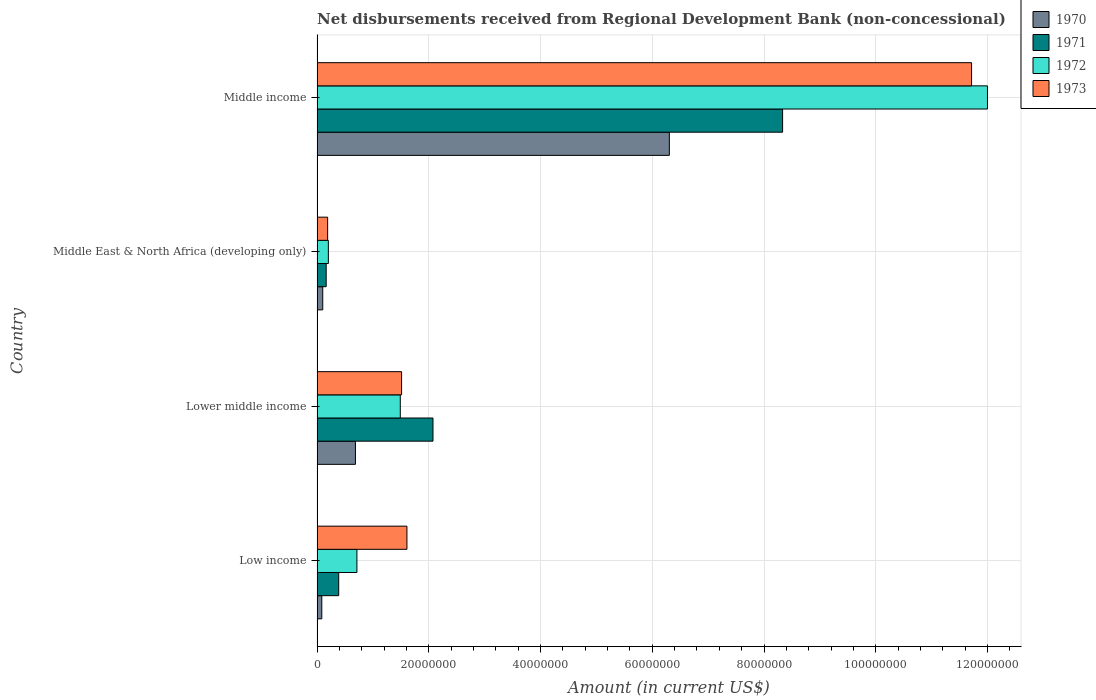How many different coloured bars are there?
Your answer should be very brief. 4. Are the number of bars per tick equal to the number of legend labels?
Provide a short and direct response. Yes. What is the label of the 2nd group of bars from the top?
Your response must be concise. Middle East & North Africa (developing only). In how many cases, is the number of bars for a given country not equal to the number of legend labels?
Provide a succinct answer. 0. What is the amount of disbursements received from Regional Development Bank in 1970 in Lower middle income?
Your response must be concise. 6.87e+06. Across all countries, what is the maximum amount of disbursements received from Regional Development Bank in 1970?
Keep it short and to the point. 6.31e+07. Across all countries, what is the minimum amount of disbursements received from Regional Development Bank in 1972?
Make the answer very short. 2.02e+06. In which country was the amount of disbursements received from Regional Development Bank in 1972 maximum?
Your answer should be very brief. Middle income. What is the total amount of disbursements received from Regional Development Bank in 1972 in the graph?
Provide a succinct answer. 1.44e+08. What is the difference between the amount of disbursements received from Regional Development Bank in 1971 in Low income and that in Middle income?
Your answer should be very brief. -7.94e+07. What is the difference between the amount of disbursements received from Regional Development Bank in 1973 in Middle East & North Africa (developing only) and the amount of disbursements received from Regional Development Bank in 1972 in Low income?
Your response must be concise. -5.24e+06. What is the average amount of disbursements received from Regional Development Bank in 1973 per country?
Offer a terse response. 3.76e+07. What is the difference between the amount of disbursements received from Regional Development Bank in 1972 and amount of disbursements received from Regional Development Bank in 1970 in Middle East & North Africa (developing only)?
Provide a succinct answer. 1.00e+06. What is the ratio of the amount of disbursements received from Regional Development Bank in 1971 in Low income to that in Middle income?
Keep it short and to the point. 0.05. Is the difference between the amount of disbursements received from Regional Development Bank in 1972 in Lower middle income and Middle income greater than the difference between the amount of disbursements received from Regional Development Bank in 1970 in Lower middle income and Middle income?
Provide a short and direct response. No. What is the difference between the highest and the second highest amount of disbursements received from Regional Development Bank in 1972?
Offer a terse response. 1.05e+08. What is the difference between the highest and the lowest amount of disbursements received from Regional Development Bank in 1972?
Your answer should be compact. 1.18e+08. What does the 2nd bar from the bottom in Middle East & North Africa (developing only) represents?
Your answer should be compact. 1971. Is it the case that in every country, the sum of the amount of disbursements received from Regional Development Bank in 1973 and amount of disbursements received from Regional Development Bank in 1971 is greater than the amount of disbursements received from Regional Development Bank in 1972?
Your answer should be very brief. Yes. How many bars are there?
Provide a succinct answer. 16. How many countries are there in the graph?
Make the answer very short. 4. Are the values on the major ticks of X-axis written in scientific E-notation?
Your answer should be very brief. No. Does the graph contain grids?
Make the answer very short. Yes. Where does the legend appear in the graph?
Provide a succinct answer. Top right. How many legend labels are there?
Provide a short and direct response. 4. What is the title of the graph?
Offer a very short reply. Net disbursements received from Regional Development Bank (non-concessional). What is the label or title of the Y-axis?
Your answer should be very brief. Country. What is the Amount (in current US$) of 1970 in Low income?
Ensure brevity in your answer.  8.50e+05. What is the Amount (in current US$) of 1971 in Low income?
Give a very brief answer. 3.88e+06. What is the Amount (in current US$) of 1972 in Low income?
Keep it short and to the point. 7.14e+06. What is the Amount (in current US$) of 1973 in Low income?
Ensure brevity in your answer.  1.61e+07. What is the Amount (in current US$) of 1970 in Lower middle income?
Offer a terse response. 6.87e+06. What is the Amount (in current US$) of 1971 in Lower middle income?
Your response must be concise. 2.08e+07. What is the Amount (in current US$) in 1972 in Lower middle income?
Your answer should be compact. 1.49e+07. What is the Amount (in current US$) of 1973 in Lower middle income?
Your answer should be very brief. 1.51e+07. What is the Amount (in current US$) of 1970 in Middle East & North Africa (developing only)?
Provide a succinct answer. 1.02e+06. What is the Amount (in current US$) of 1971 in Middle East & North Africa (developing only)?
Your answer should be very brief. 1.64e+06. What is the Amount (in current US$) of 1972 in Middle East & North Africa (developing only)?
Offer a terse response. 2.02e+06. What is the Amount (in current US$) in 1973 in Middle East & North Africa (developing only)?
Offer a terse response. 1.90e+06. What is the Amount (in current US$) of 1970 in Middle income?
Offer a very short reply. 6.31e+07. What is the Amount (in current US$) of 1971 in Middle income?
Your response must be concise. 8.33e+07. What is the Amount (in current US$) of 1972 in Middle income?
Your response must be concise. 1.20e+08. What is the Amount (in current US$) in 1973 in Middle income?
Make the answer very short. 1.17e+08. Across all countries, what is the maximum Amount (in current US$) in 1970?
Give a very brief answer. 6.31e+07. Across all countries, what is the maximum Amount (in current US$) in 1971?
Your answer should be compact. 8.33e+07. Across all countries, what is the maximum Amount (in current US$) of 1972?
Provide a succinct answer. 1.20e+08. Across all countries, what is the maximum Amount (in current US$) of 1973?
Give a very brief answer. 1.17e+08. Across all countries, what is the minimum Amount (in current US$) in 1970?
Provide a short and direct response. 8.50e+05. Across all countries, what is the minimum Amount (in current US$) in 1971?
Your answer should be very brief. 1.64e+06. Across all countries, what is the minimum Amount (in current US$) in 1972?
Keep it short and to the point. 2.02e+06. Across all countries, what is the minimum Amount (in current US$) of 1973?
Ensure brevity in your answer.  1.90e+06. What is the total Amount (in current US$) of 1970 in the graph?
Give a very brief answer. 7.18e+07. What is the total Amount (in current US$) of 1971 in the graph?
Provide a short and direct response. 1.10e+08. What is the total Amount (in current US$) of 1972 in the graph?
Ensure brevity in your answer.  1.44e+08. What is the total Amount (in current US$) in 1973 in the graph?
Make the answer very short. 1.50e+08. What is the difference between the Amount (in current US$) in 1970 in Low income and that in Lower middle income?
Ensure brevity in your answer.  -6.02e+06. What is the difference between the Amount (in current US$) in 1971 in Low income and that in Lower middle income?
Provide a short and direct response. -1.69e+07. What is the difference between the Amount (in current US$) of 1972 in Low income and that in Lower middle income?
Make the answer very short. -7.76e+06. What is the difference between the Amount (in current US$) in 1973 in Low income and that in Lower middle income?
Your answer should be very brief. 9.55e+05. What is the difference between the Amount (in current US$) of 1970 in Low income and that in Middle East & North Africa (developing only)?
Provide a short and direct response. -1.71e+05. What is the difference between the Amount (in current US$) in 1971 in Low income and that in Middle East & North Africa (developing only)?
Your response must be concise. 2.24e+06. What is the difference between the Amount (in current US$) of 1972 in Low income and that in Middle East & North Africa (developing only)?
Give a very brief answer. 5.11e+06. What is the difference between the Amount (in current US$) in 1973 in Low income and that in Middle East & North Africa (developing only)?
Keep it short and to the point. 1.42e+07. What is the difference between the Amount (in current US$) in 1970 in Low income and that in Middle income?
Make the answer very short. -6.22e+07. What is the difference between the Amount (in current US$) of 1971 in Low income and that in Middle income?
Offer a terse response. -7.94e+07. What is the difference between the Amount (in current US$) in 1972 in Low income and that in Middle income?
Provide a succinct answer. -1.13e+08. What is the difference between the Amount (in current US$) of 1973 in Low income and that in Middle income?
Your answer should be very brief. -1.01e+08. What is the difference between the Amount (in current US$) in 1970 in Lower middle income and that in Middle East & North Africa (developing only)?
Your response must be concise. 5.85e+06. What is the difference between the Amount (in current US$) of 1971 in Lower middle income and that in Middle East & North Africa (developing only)?
Offer a terse response. 1.91e+07. What is the difference between the Amount (in current US$) in 1972 in Lower middle income and that in Middle East & North Africa (developing only)?
Your response must be concise. 1.29e+07. What is the difference between the Amount (in current US$) in 1973 in Lower middle income and that in Middle East & North Africa (developing only)?
Provide a succinct answer. 1.32e+07. What is the difference between the Amount (in current US$) in 1970 in Lower middle income and that in Middle income?
Provide a short and direct response. -5.62e+07. What is the difference between the Amount (in current US$) in 1971 in Lower middle income and that in Middle income?
Offer a terse response. -6.26e+07. What is the difference between the Amount (in current US$) of 1972 in Lower middle income and that in Middle income?
Offer a very short reply. -1.05e+08. What is the difference between the Amount (in current US$) in 1973 in Lower middle income and that in Middle income?
Ensure brevity in your answer.  -1.02e+08. What is the difference between the Amount (in current US$) in 1970 in Middle East & North Africa (developing only) and that in Middle income?
Provide a short and direct response. -6.20e+07. What is the difference between the Amount (in current US$) of 1971 in Middle East & North Africa (developing only) and that in Middle income?
Offer a very short reply. -8.17e+07. What is the difference between the Amount (in current US$) of 1972 in Middle East & North Africa (developing only) and that in Middle income?
Ensure brevity in your answer.  -1.18e+08. What is the difference between the Amount (in current US$) of 1973 in Middle East & North Africa (developing only) and that in Middle income?
Your answer should be very brief. -1.15e+08. What is the difference between the Amount (in current US$) of 1970 in Low income and the Amount (in current US$) of 1971 in Lower middle income?
Ensure brevity in your answer.  -1.99e+07. What is the difference between the Amount (in current US$) in 1970 in Low income and the Amount (in current US$) in 1972 in Lower middle income?
Your answer should be compact. -1.40e+07. What is the difference between the Amount (in current US$) in 1970 in Low income and the Amount (in current US$) in 1973 in Lower middle income?
Offer a very short reply. -1.43e+07. What is the difference between the Amount (in current US$) of 1971 in Low income and the Amount (in current US$) of 1972 in Lower middle income?
Offer a terse response. -1.10e+07. What is the difference between the Amount (in current US$) in 1971 in Low income and the Amount (in current US$) in 1973 in Lower middle income?
Provide a succinct answer. -1.13e+07. What is the difference between the Amount (in current US$) in 1972 in Low income and the Amount (in current US$) in 1973 in Lower middle income?
Give a very brief answer. -8.00e+06. What is the difference between the Amount (in current US$) in 1970 in Low income and the Amount (in current US$) in 1971 in Middle East & North Africa (developing only)?
Your answer should be very brief. -7.85e+05. What is the difference between the Amount (in current US$) in 1970 in Low income and the Amount (in current US$) in 1972 in Middle East & North Africa (developing only)?
Your response must be concise. -1.17e+06. What is the difference between the Amount (in current US$) in 1970 in Low income and the Amount (in current US$) in 1973 in Middle East & North Africa (developing only)?
Ensure brevity in your answer.  -1.05e+06. What is the difference between the Amount (in current US$) in 1971 in Low income and the Amount (in current US$) in 1972 in Middle East & North Africa (developing only)?
Provide a short and direct response. 1.85e+06. What is the difference between the Amount (in current US$) of 1971 in Low income and the Amount (in current US$) of 1973 in Middle East & North Africa (developing only)?
Make the answer very short. 1.98e+06. What is the difference between the Amount (in current US$) in 1972 in Low income and the Amount (in current US$) in 1973 in Middle East & North Africa (developing only)?
Offer a terse response. 5.24e+06. What is the difference between the Amount (in current US$) of 1970 in Low income and the Amount (in current US$) of 1971 in Middle income?
Offer a very short reply. -8.25e+07. What is the difference between the Amount (in current US$) in 1970 in Low income and the Amount (in current US$) in 1972 in Middle income?
Your answer should be very brief. -1.19e+08. What is the difference between the Amount (in current US$) in 1970 in Low income and the Amount (in current US$) in 1973 in Middle income?
Ensure brevity in your answer.  -1.16e+08. What is the difference between the Amount (in current US$) of 1971 in Low income and the Amount (in current US$) of 1972 in Middle income?
Provide a succinct answer. -1.16e+08. What is the difference between the Amount (in current US$) of 1971 in Low income and the Amount (in current US$) of 1973 in Middle income?
Make the answer very short. -1.13e+08. What is the difference between the Amount (in current US$) in 1972 in Low income and the Amount (in current US$) in 1973 in Middle income?
Provide a succinct answer. -1.10e+08. What is the difference between the Amount (in current US$) of 1970 in Lower middle income and the Amount (in current US$) of 1971 in Middle East & North Africa (developing only)?
Your answer should be very brief. 5.24e+06. What is the difference between the Amount (in current US$) of 1970 in Lower middle income and the Amount (in current US$) of 1972 in Middle East & North Africa (developing only)?
Your answer should be compact. 4.85e+06. What is the difference between the Amount (in current US$) in 1970 in Lower middle income and the Amount (in current US$) in 1973 in Middle East & North Africa (developing only)?
Provide a succinct answer. 4.98e+06. What is the difference between the Amount (in current US$) of 1971 in Lower middle income and the Amount (in current US$) of 1972 in Middle East & North Africa (developing only)?
Provide a short and direct response. 1.87e+07. What is the difference between the Amount (in current US$) in 1971 in Lower middle income and the Amount (in current US$) in 1973 in Middle East & North Africa (developing only)?
Your answer should be very brief. 1.89e+07. What is the difference between the Amount (in current US$) in 1972 in Lower middle income and the Amount (in current US$) in 1973 in Middle East & North Africa (developing only)?
Provide a succinct answer. 1.30e+07. What is the difference between the Amount (in current US$) in 1970 in Lower middle income and the Amount (in current US$) in 1971 in Middle income?
Provide a succinct answer. -7.65e+07. What is the difference between the Amount (in current US$) in 1970 in Lower middle income and the Amount (in current US$) in 1972 in Middle income?
Your response must be concise. -1.13e+08. What is the difference between the Amount (in current US$) in 1970 in Lower middle income and the Amount (in current US$) in 1973 in Middle income?
Ensure brevity in your answer.  -1.10e+08. What is the difference between the Amount (in current US$) in 1971 in Lower middle income and the Amount (in current US$) in 1972 in Middle income?
Your answer should be very brief. -9.92e+07. What is the difference between the Amount (in current US$) in 1971 in Lower middle income and the Amount (in current US$) in 1973 in Middle income?
Make the answer very short. -9.64e+07. What is the difference between the Amount (in current US$) in 1972 in Lower middle income and the Amount (in current US$) in 1973 in Middle income?
Your response must be concise. -1.02e+08. What is the difference between the Amount (in current US$) in 1970 in Middle East & North Africa (developing only) and the Amount (in current US$) in 1971 in Middle income?
Ensure brevity in your answer.  -8.23e+07. What is the difference between the Amount (in current US$) in 1970 in Middle East & North Africa (developing only) and the Amount (in current US$) in 1972 in Middle income?
Make the answer very short. -1.19e+08. What is the difference between the Amount (in current US$) of 1970 in Middle East & North Africa (developing only) and the Amount (in current US$) of 1973 in Middle income?
Keep it short and to the point. -1.16e+08. What is the difference between the Amount (in current US$) of 1971 in Middle East & North Africa (developing only) and the Amount (in current US$) of 1972 in Middle income?
Provide a succinct answer. -1.18e+08. What is the difference between the Amount (in current US$) of 1971 in Middle East & North Africa (developing only) and the Amount (in current US$) of 1973 in Middle income?
Your answer should be compact. -1.16e+08. What is the difference between the Amount (in current US$) in 1972 in Middle East & North Africa (developing only) and the Amount (in current US$) in 1973 in Middle income?
Give a very brief answer. -1.15e+08. What is the average Amount (in current US$) in 1970 per country?
Provide a succinct answer. 1.79e+07. What is the average Amount (in current US$) in 1971 per country?
Make the answer very short. 2.74e+07. What is the average Amount (in current US$) in 1972 per country?
Give a very brief answer. 3.60e+07. What is the average Amount (in current US$) in 1973 per country?
Ensure brevity in your answer.  3.76e+07. What is the difference between the Amount (in current US$) in 1970 and Amount (in current US$) in 1971 in Low income?
Your response must be concise. -3.02e+06. What is the difference between the Amount (in current US$) in 1970 and Amount (in current US$) in 1972 in Low income?
Your answer should be very brief. -6.29e+06. What is the difference between the Amount (in current US$) in 1970 and Amount (in current US$) in 1973 in Low income?
Your response must be concise. -1.52e+07. What is the difference between the Amount (in current US$) in 1971 and Amount (in current US$) in 1972 in Low income?
Ensure brevity in your answer.  -3.26e+06. What is the difference between the Amount (in current US$) of 1971 and Amount (in current US$) of 1973 in Low income?
Ensure brevity in your answer.  -1.22e+07. What is the difference between the Amount (in current US$) in 1972 and Amount (in current US$) in 1973 in Low income?
Keep it short and to the point. -8.95e+06. What is the difference between the Amount (in current US$) in 1970 and Amount (in current US$) in 1971 in Lower middle income?
Give a very brief answer. -1.39e+07. What is the difference between the Amount (in current US$) of 1970 and Amount (in current US$) of 1972 in Lower middle income?
Keep it short and to the point. -8.03e+06. What is the difference between the Amount (in current US$) in 1970 and Amount (in current US$) in 1973 in Lower middle income?
Offer a terse response. -8.26e+06. What is the difference between the Amount (in current US$) in 1971 and Amount (in current US$) in 1972 in Lower middle income?
Offer a very short reply. 5.85e+06. What is the difference between the Amount (in current US$) in 1971 and Amount (in current US$) in 1973 in Lower middle income?
Provide a succinct answer. 5.62e+06. What is the difference between the Amount (in current US$) of 1972 and Amount (in current US$) of 1973 in Lower middle income?
Keep it short and to the point. -2.36e+05. What is the difference between the Amount (in current US$) in 1970 and Amount (in current US$) in 1971 in Middle East & North Africa (developing only)?
Make the answer very short. -6.14e+05. What is the difference between the Amount (in current US$) of 1970 and Amount (in current US$) of 1972 in Middle East & North Africa (developing only)?
Your answer should be very brief. -1.00e+06. What is the difference between the Amount (in current US$) of 1970 and Amount (in current US$) of 1973 in Middle East & North Africa (developing only)?
Your answer should be very brief. -8.75e+05. What is the difference between the Amount (in current US$) of 1971 and Amount (in current US$) of 1972 in Middle East & North Africa (developing only)?
Provide a succinct answer. -3.89e+05. What is the difference between the Amount (in current US$) in 1971 and Amount (in current US$) in 1973 in Middle East & North Africa (developing only)?
Your answer should be very brief. -2.61e+05. What is the difference between the Amount (in current US$) in 1972 and Amount (in current US$) in 1973 in Middle East & North Africa (developing only)?
Provide a succinct answer. 1.28e+05. What is the difference between the Amount (in current US$) in 1970 and Amount (in current US$) in 1971 in Middle income?
Keep it short and to the point. -2.03e+07. What is the difference between the Amount (in current US$) in 1970 and Amount (in current US$) in 1972 in Middle income?
Offer a very short reply. -5.69e+07. What is the difference between the Amount (in current US$) in 1970 and Amount (in current US$) in 1973 in Middle income?
Offer a terse response. -5.41e+07. What is the difference between the Amount (in current US$) of 1971 and Amount (in current US$) of 1972 in Middle income?
Provide a short and direct response. -3.67e+07. What is the difference between the Amount (in current US$) in 1971 and Amount (in current US$) in 1973 in Middle income?
Provide a succinct answer. -3.38e+07. What is the difference between the Amount (in current US$) of 1972 and Amount (in current US$) of 1973 in Middle income?
Provide a succinct answer. 2.85e+06. What is the ratio of the Amount (in current US$) of 1970 in Low income to that in Lower middle income?
Provide a short and direct response. 0.12. What is the ratio of the Amount (in current US$) in 1971 in Low income to that in Lower middle income?
Your response must be concise. 0.19. What is the ratio of the Amount (in current US$) in 1972 in Low income to that in Lower middle income?
Your answer should be very brief. 0.48. What is the ratio of the Amount (in current US$) in 1973 in Low income to that in Lower middle income?
Provide a succinct answer. 1.06. What is the ratio of the Amount (in current US$) in 1970 in Low income to that in Middle East & North Africa (developing only)?
Provide a short and direct response. 0.83. What is the ratio of the Amount (in current US$) of 1971 in Low income to that in Middle East & North Africa (developing only)?
Ensure brevity in your answer.  2.37. What is the ratio of the Amount (in current US$) of 1972 in Low income to that in Middle East & North Africa (developing only)?
Make the answer very short. 3.53. What is the ratio of the Amount (in current US$) of 1973 in Low income to that in Middle East & North Africa (developing only)?
Ensure brevity in your answer.  8.49. What is the ratio of the Amount (in current US$) of 1970 in Low income to that in Middle income?
Provide a short and direct response. 0.01. What is the ratio of the Amount (in current US$) in 1971 in Low income to that in Middle income?
Ensure brevity in your answer.  0.05. What is the ratio of the Amount (in current US$) in 1972 in Low income to that in Middle income?
Your response must be concise. 0.06. What is the ratio of the Amount (in current US$) of 1973 in Low income to that in Middle income?
Provide a short and direct response. 0.14. What is the ratio of the Amount (in current US$) in 1970 in Lower middle income to that in Middle East & North Africa (developing only)?
Your answer should be compact. 6.73. What is the ratio of the Amount (in current US$) in 1971 in Lower middle income to that in Middle East & North Africa (developing only)?
Offer a very short reply. 12.69. What is the ratio of the Amount (in current US$) of 1972 in Lower middle income to that in Middle East & North Africa (developing only)?
Give a very brief answer. 7.36. What is the ratio of the Amount (in current US$) of 1973 in Lower middle income to that in Middle East & North Africa (developing only)?
Your answer should be compact. 7.98. What is the ratio of the Amount (in current US$) of 1970 in Lower middle income to that in Middle income?
Give a very brief answer. 0.11. What is the ratio of the Amount (in current US$) of 1971 in Lower middle income to that in Middle income?
Your response must be concise. 0.25. What is the ratio of the Amount (in current US$) in 1972 in Lower middle income to that in Middle income?
Offer a terse response. 0.12. What is the ratio of the Amount (in current US$) in 1973 in Lower middle income to that in Middle income?
Provide a succinct answer. 0.13. What is the ratio of the Amount (in current US$) in 1970 in Middle East & North Africa (developing only) to that in Middle income?
Offer a very short reply. 0.02. What is the ratio of the Amount (in current US$) in 1971 in Middle East & North Africa (developing only) to that in Middle income?
Provide a short and direct response. 0.02. What is the ratio of the Amount (in current US$) in 1972 in Middle East & North Africa (developing only) to that in Middle income?
Offer a terse response. 0.02. What is the ratio of the Amount (in current US$) in 1973 in Middle East & North Africa (developing only) to that in Middle income?
Your response must be concise. 0.02. What is the difference between the highest and the second highest Amount (in current US$) in 1970?
Give a very brief answer. 5.62e+07. What is the difference between the highest and the second highest Amount (in current US$) of 1971?
Provide a short and direct response. 6.26e+07. What is the difference between the highest and the second highest Amount (in current US$) in 1972?
Your response must be concise. 1.05e+08. What is the difference between the highest and the second highest Amount (in current US$) in 1973?
Your answer should be very brief. 1.01e+08. What is the difference between the highest and the lowest Amount (in current US$) in 1970?
Give a very brief answer. 6.22e+07. What is the difference between the highest and the lowest Amount (in current US$) in 1971?
Make the answer very short. 8.17e+07. What is the difference between the highest and the lowest Amount (in current US$) in 1972?
Ensure brevity in your answer.  1.18e+08. What is the difference between the highest and the lowest Amount (in current US$) in 1973?
Your response must be concise. 1.15e+08. 